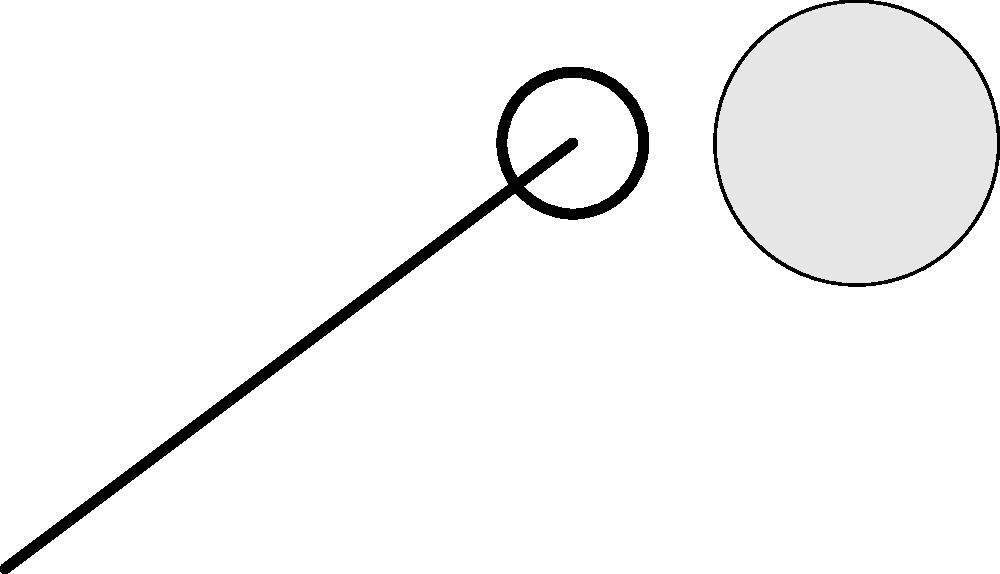In a boxing match, a punch is thrown with a force of 800 N, making contact with the opponent for 0.01 seconds. If the mass of the boxer's fist and forearm is 4 kg, what is the change in momentum of the boxer's arm during the punch? Let's approach this step-by-step:

1) First, recall the impulse-momentum theorem:
   
   $F \cdot \Delta t = \Delta p$

   Where $F$ is the average force, $\Delta t$ is the time interval, and $\Delta p$ is the change in momentum.

2) We are given:
   - Force ($F$) = 800 N
   - Time of contact ($\Delta t$) = 0.01 s
   - Mass of fist and forearm ($m$) = 4 kg

3) Let's substitute these values into the impulse-momentum equation:

   $800 \text{ N} \cdot 0.01 \text{ s} = \Delta p$

4) Simplify:

   $8 \text{ N}\cdot\text{s} = \Delta p$

5) Therefore, the change in momentum is 8 N·s or 8 kg·m/s.

Note: In boxing, the actual change in momentum might be slightly less due to the opponent's movement and other factors, but this calculation gives us the theoretical maximum based on the given force and contact time.
Answer: 8 kg·m/s 